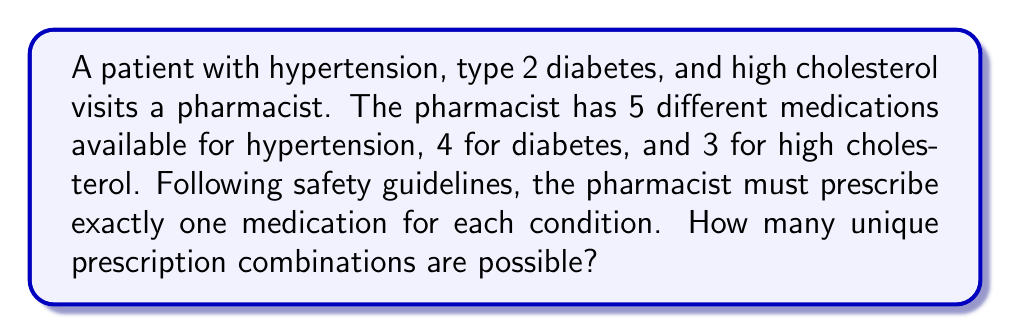Can you solve this math problem? To solve this problem, we'll use the multiplication principle of counting. Here's a step-by-step explanation:

1) For hypertension:
   - There are 5 medication options
   - The pharmacist must choose 1

2) For diabetes:
   - There are 4 medication options
   - The pharmacist must choose 1

3) For high cholesterol:
   - There are 3 medication options
   - The pharmacist must choose 1

4) For each condition, the choice of medication is independent of the others.

5) Therefore, we multiply the number of choices for each condition:

   $$ \text{Total combinations} = 5 \times 4 \times 3 $$

6) Calculating:
   $$ 5 \times 4 \times 3 = 60 $$

Thus, there are 60 unique prescription combinations possible.
Answer: 60 